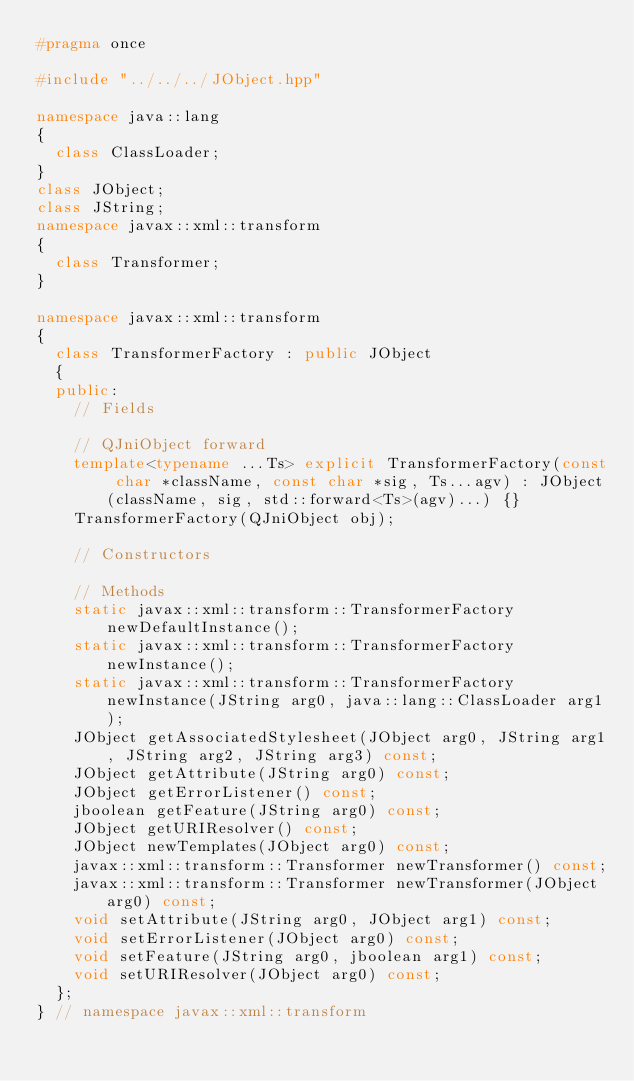<code> <loc_0><loc_0><loc_500><loc_500><_C++_>#pragma once

#include "../../../JObject.hpp"

namespace java::lang
{
	class ClassLoader;
}
class JObject;
class JString;
namespace javax::xml::transform
{
	class Transformer;
}

namespace javax::xml::transform
{
	class TransformerFactory : public JObject
	{
	public:
		// Fields
		
		// QJniObject forward
		template<typename ...Ts> explicit TransformerFactory(const char *className, const char *sig, Ts...agv) : JObject(className, sig, std::forward<Ts>(agv)...) {}
		TransformerFactory(QJniObject obj);
		
		// Constructors
		
		// Methods
		static javax::xml::transform::TransformerFactory newDefaultInstance();
		static javax::xml::transform::TransformerFactory newInstance();
		static javax::xml::transform::TransformerFactory newInstance(JString arg0, java::lang::ClassLoader arg1);
		JObject getAssociatedStylesheet(JObject arg0, JString arg1, JString arg2, JString arg3) const;
		JObject getAttribute(JString arg0) const;
		JObject getErrorListener() const;
		jboolean getFeature(JString arg0) const;
		JObject getURIResolver() const;
		JObject newTemplates(JObject arg0) const;
		javax::xml::transform::Transformer newTransformer() const;
		javax::xml::transform::Transformer newTransformer(JObject arg0) const;
		void setAttribute(JString arg0, JObject arg1) const;
		void setErrorListener(JObject arg0) const;
		void setFeature(JString arg0, jboolean arg1) const;
		void setURIResolver(JObject arg0) const;
	};
} // namespace javax::xml::transform

</code> 